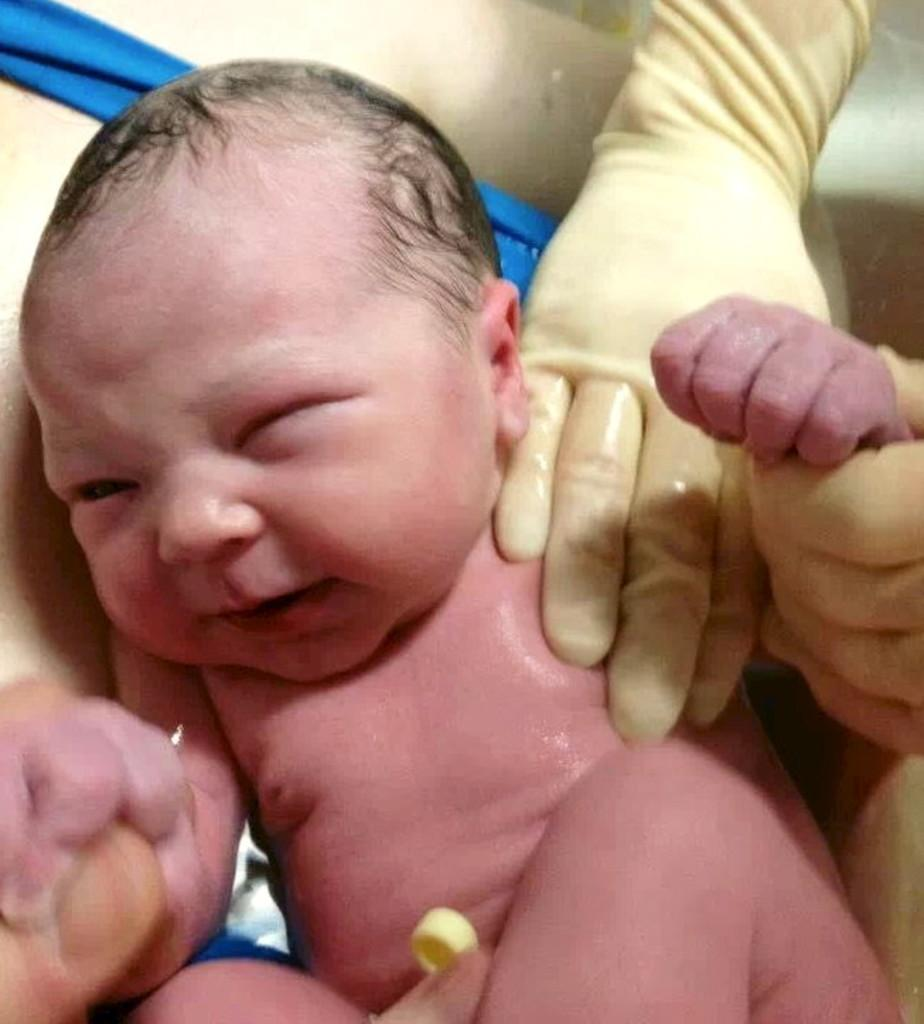What is the main subject of the image? There is a newborn baby in the image. What is the baby doing in the image? The baby is holding the finger of a person. Whose hands are visible in the image? The hands of the other person are visible in the image. What type of thread is being used to sew the baby's apparel in the image? There is no thread or apparel visible in the image; it only shows a newborn baby holding a person's finger. 